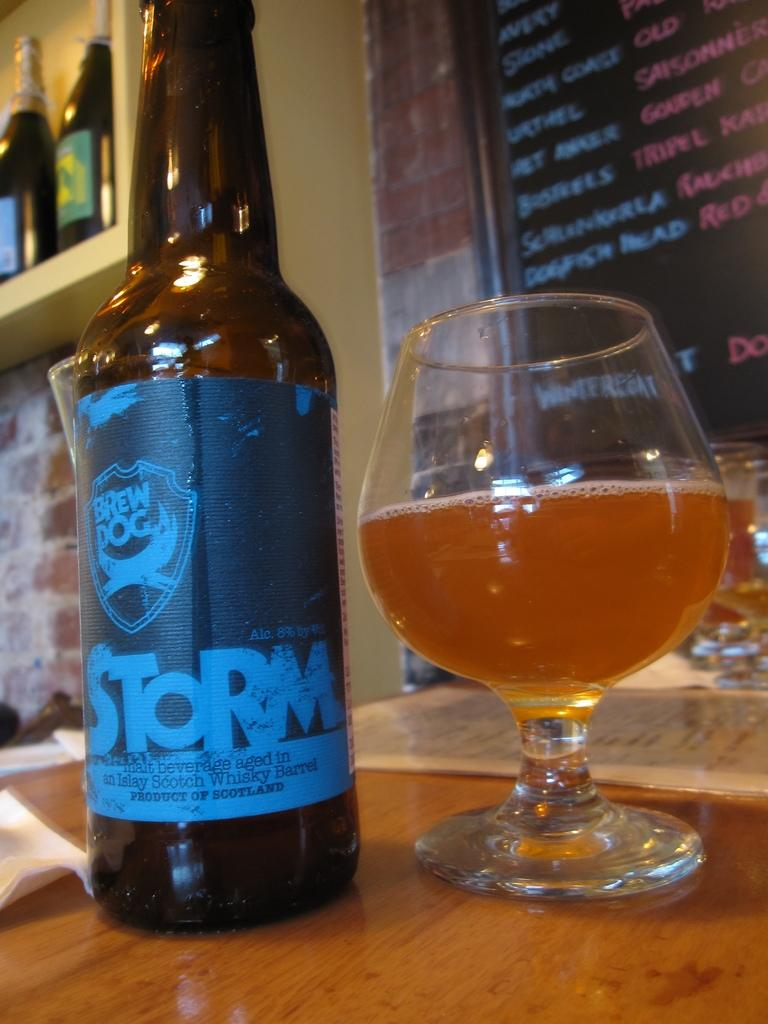<image>
Share a concise interpretation of the image provided. the word storm that is on a bottle 